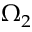<formula> <loc_0><loc_0><loc_500><loc_500>\Omega _ { 2 }</formula> 